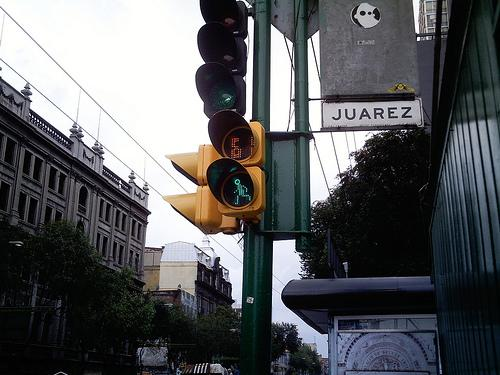Question: why is the sky clear?
Choices:
A. No clouds.
B. No rain.
C. It's daylight.
D. It's sunset.
Answer with the letter. Answer: C Question: what is on the right side?
Choices:
A. The car.
B. Person on bike.
C. Deer.
D. The sign.
Answer with the letter. Answer: D Question: what is green?
Choices:
A. Grass.
B. Tea.
C. The trees.
D. Paint.
Answer with the letter. Answer: C Question: what color is the light?
Choices:
A. Red.
B. Green.
C. Yellow.
D. Blue.
Answer with the letter. Answer: B 